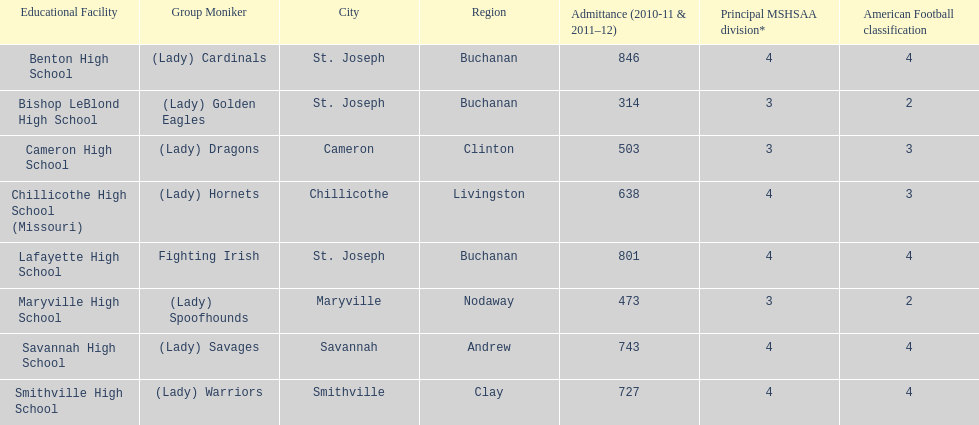How many teams are named after birds? 2. 